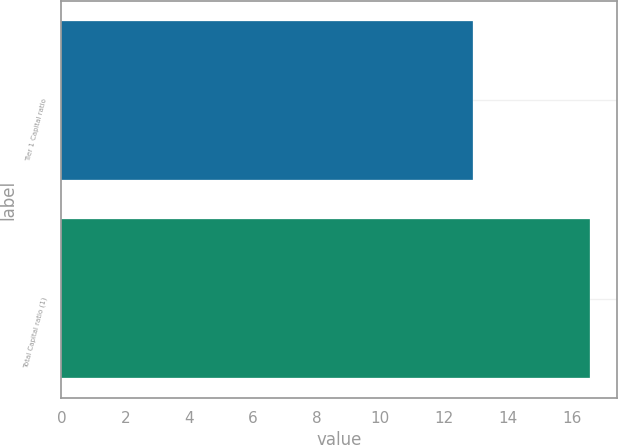Convert chart to OTSL. <chart><loc_0><loc_0><loc_500><loc_500><bar_chart><fcel>Tier 1 Capital ratio<fcel>Total Capital ratio (1)<nl><fcel>12.91<fcel>16.59<nl></chart> 